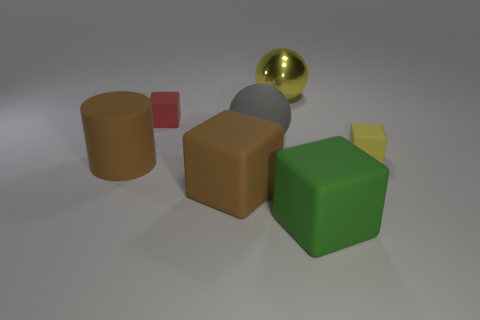Add 3 brown matte cubes. How many objects exist? 10 Subtract all balls. How many objects are left? 5 Subtract 0 red spheres. How many objects are left? 7 Subtract all large yellow metal balls. Subtract all large gray balls. How many objects are left? 5 Add 6 large balls. How many large balls are left? 8 Add 7 big cyan rubber cubes. How many big cyan rubber cubes exist? 7 